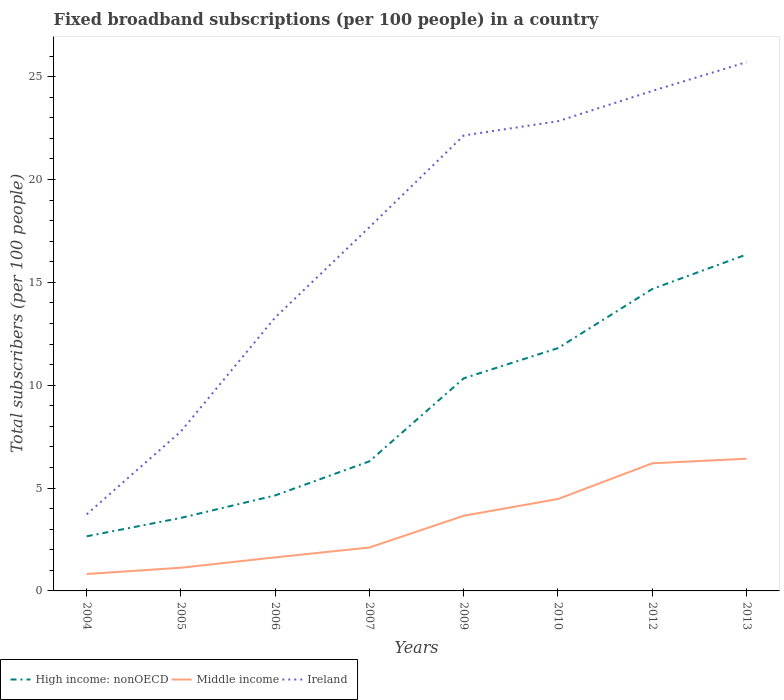How many different coloured lines are there?
Provide a succinct answer. 3. Does the line corresponding to Ireland intersect with the line corresponding to High income: nonOECD?
Ensure brevity in your answer.  No. Across all years, what is the maximum number of broadband subscriptions in High income: nonOECD?
Offer a terse response. 2.66. In which year was the number of broadband subscriptions in High income: nonOECD maximum?
Offer a very short reply. 2004. What is the total number of broadband subscriptions in High income: nonOECD in the graph?
Your answer should be very brief. -10.03. What is the difference between the highest and the second highest number of broadband subscriptions in Ireland?
Ensure brevity in your answer.  21.98. Is the number of broadband subscriptions in Ireland strictly greater than the number of broadband subscriptions in High income: nonOECD over the years?
Provide a succinct answer. No. How many lines are there?
Your response must be concise. 3. How many years are there in the graph?
Ensure brevity in your answer.  8. What is the difference between two consecutive major ticks on the Y-axis?
Your answer should be compact. 5. Does the graph contain grids?
Ensure brevity in your answer.  No. Where does the legend appear in the graph?
Your answer should be very brief. Bottom left. How many legend labels are there?
Your answer should be compact. 3. How are the legend labels stacked?
Give a very brief answer. Horizontal. What is the title of the graph?
Provide a succinct answer. Fixed broadband subscriptions (per 100 people) in a country. Does "Mali" appear as one of the legend labels in the graph?
Provide a short and direct response. No. What is the label or title of the Y-axis?
Your answer should be compact. Total subscribers (per 100 people). What is the Total subscribers (per 100 people) of High income: nonOECD in 2004?
Give a very brief answer. 2.66. What is the Total subscribers (per 100 people) in Middle income in 2004?
Give a very brief answer. 0.82. What is the Total subscribers (per 100 people) of Ireland in 2004?
Offer a terse response. 3.72. What is the Total subscribers (per 100 people) in High income: nonOECD in 2005?
Your answer should be very brief. 3.55. What is the Total subscribers (per 100 people) of Middle income in 2005?
Your answer should be compact. 1.13. What is the Total subscribers (per 100 people) in Ireland in 2005?
Offer a terse response. 7.76. What is the Total subscribers (per 100 people) of High income: nonOECD in 2006?
Ensure brevity in your answer.  4.64. What is the Total subscribers (per 100 people) in Middle income in 2006?
Give a very brief answer. 1.63. What is the Total subscribers (per 100 people) of Ireland in 2006?
Ensure brevity in your answer.  13.29. What is the Total subscribers (per 100 people) in High income: nonOECD in 2007?
Provide a succinct answer. 6.3. What is the Total subscribers (per 100 people) of Middle income in 2007?
Offer a very short reply. 2.11. What is the Total subscribers (per 100 people) of Ireland in 2007?
Give a very brief answer. 17.68. What is the Total subscribers (per 100 people) of High income: nonOECD in 2009?
Your answer should be compact. 10.33. What is the Total subscribers (per 100 people) in Middle income in 2009?
Provide a succinct answer. 3.65. What is the Total subscribers (per 100 people) in Ireland in 2009?
Make the answer very short. 22.14. What is the Total subscribers (per 100 people) of High income: nonOECD in 2010?
Provide a short and direct response. 11.8. What is the Total subscribers (per 100 people) in Middle income in 2010?
Your response must be concise. 4.47. What is the Total subscribers (per 100 people) of Ireland in 2010?
Your response must be concise. 22.83. What is the Total subscribers (per 100 people) in High income: nonOECD in 2012?
Give a very brief answer. 14.67. What is the Total subscribers (per 100 people) in Middle income in 2012?
Ensure brevity in your answer.  6.2. What is the Total subscribers (per 100 people) of Ireland in 2012?
Provide a short and direct response. 24.3. What is the Total subscribers (per 100 people) of High income: nonOECD in 2013?
Offer a very short reply. 16.35. What is the Total subscribers (per 100 people) of Middle income in 2013?
Offer a terse response. 6.43. What is the Total subscribers (per 100 people) of Ireland in 2013?
Offer a terse response. 25.7. Across all years, what is the maximum Total subscribers (per 100 people) in High income: nonOECD?
Provide a short and direct response. 16.35. Across all years, what is the maximum Total subscribers (per 100 people) in Middle income?
Ensure brevity in your answer.  6.43. Across all years, what is the maximum Total subscribers (per 100 people) of Ireland?
Ensure brevity in your answer.  25.7. Across all years, what is the minimum Total subscribers (per 100 people) of High income: nonOECD?
Provide a short and direct response. 2.66. Across all years, what is the minimum Total subscribers (per 100 people) in Middle income?
Ensure brevity in your answer.  0.82. Across all years, what is the minimum Total subscribers (per 100 people) of Ireland?
Make the answer very short. 3.72. What is the total Total subscribers (per 100 people) of High income: nonOECD in the graph?
Give a very brief answer. 70.31. What is the total Total subscribers (per 100 people) in Middle income in the graph?
Keep it short and to the point. 26.44. What is the total Total subscribers (per 100 people) in Ireland in the graph?
Your answer should be very brief. 137.43. What is the difference between the Total subscribers (per 100 people) of High income: nonOECD in 2004 and that in 2005?
Ensure brevity in your answer.  -0.89. What is the difference between the Total subscribers (per 100 people) in Middle income in 2004 and that in 2005?
Your response must be concise. -0.3. What is the difference between the Total subscribers (per 100 people) in Ireland in 2004 and that in 2005?
Offer a very short reply. -4.03. What is the difference between the Total subscribers (per 100 people) in High income: nonOECD in 2004 and that in 2006?
Ensure brevity in your answer.  -1.99. What is the difference between the Total subscribers (per 100 people) in Middle income in 2004 and that in 2006?
Keep it short and to the point. -0.81. What is the difference between the Total subscribers (per 100 people) of Ireland in 2004 and that in 2006?
Provide a succinct answer. -9.57. What is the difference between the Total subscribers (per 100 people) of High income: nonOECD in 2004 and that in 2007?
Keep it short and to the point. -3.65. What is the difference between the Total subscribers (per 100 people) in Middle income in 2004 and that in 2007?
Give a very brief answer. -1.29. What is the difference between the Total subscribers (per 100 people) of Ireland in 2004 and that in 2007?
Provide a succinct answer. -13.96. What is the difference between the Total subscribers (per 100 people) in High income: nonOECD in 2004 and that in 2009?
Keep it short and to the point. -7.68. What is the difference between the Total subscribers (per 100 people) of Middle income in 2004 and that in 2009?
Provide a succinct answer. -2.83. What is the difference between the Total subscribers (per 100 people) in Ireland in 2004 and that in 2009?
Ensure brevity in your answer.  -18.42. What is the difference between the Total subscribers (per 100 people) in High income: nonOECD in 2004 and that in 2010?
Your response must be concise. -9.15. What is the difference between the Total subscribers (per 100 people) of Middle income in 2004 and that in 2010?
Offer a very short reply. -3.64. What is the difference between the Total subscribers (per 100 people) in Ireland in 2004 and that in 2010?
Keep it short and to the point. -19.11. What is the difference between the Total subscribers (per 100 people) in High income: nonOECD in 2004 and that in 2012?
Offer a very short reply. -12.02. What is the difference between the Total subscribers (per 100 people) in Middle income in 2004 and that in 2012?
Give a very brief answer. -5.38. What is the difference between the Total subscribers (per 100 people) in Ireland in 2004 and that in 2012?
Keep it short and to the point. -20.58. What is the difference between the Total subscribers (per 100 people) of High income: nonOECD in 2004 and that in 2013?
Keep it short and to the point. -13.7. What is the difference between the Total subscribers (per 100 people) of Middle income in 2004 and that in 2013?
Make the answer very short. -5.6. What is the difference between the Total subscribers (per 100 people) of Ireland in 2004 and that in 2013?
Make the answer very short. -21.98. What is the difference between the Total subscribers (per 100 people) in High income: nonOECD in 2005 and that in 2006?
Make the answer very short. -1.09. What is the difference between the Total subscribers (per 100 people) of Middle income in 2005 and that in 2006?
Provide a short and direct response. -0.5. What is the difference between the Total subscribers (per 100 people) in Ireland in 2005 and that in 2006?
Your response must be concise. -5.54. What is the difference between the Total subscribers (per 100 people) in High income: nonOECD in 2005 and that in 2007?
Your answer should be compact. -2.75. What is the difference between the Total subscribers (per 100 people) in Middle income in 2005 and that in 2007?
Provide a succinct answer. -0.98. What is the difference between the Total subscribers (per 100 people) of Ireland in 2005 and that in 2007?
Your answer should be very brief. -9.93. What is the difference between the Total subscribers (per 100 people) of High income: nonOECD in 2005 and that in 2009?
Provide a succinct answer. -6.78. What is the difference between the Total subscribers (per 100 people) of Middle income in 2005 and that in 2009?
Offer a terse response. -2.53. What is the difference between the Total subscribers (per 100 people) of Ireland in 2005 and that in 2009?
Your response must be concise. -14.38. What is the difference between the Total subscribers (per 100 people) of High income: nonOECD in 2005 and that in 2010?
Keep it short and to the point. -8.25. What is the difference between the Total subscribers (per 100 people) of Middle income in 2005 and that in 2010?
Provide a short and direct response. -3.34. What is the difference between the Total subscribers (per 100 people) of Ireland in 2005 and that in 2010?
Provide a succinct answer. -15.07. What is the difference between the Total subscribers (per 100 people) in High income: nonOECD in 2005 and that in 2012?
Provide a succinct answer. -11.12. What is the difference between the Total subscribers (per 100 people) in Middle income in 2005 and that in 2012?
Your answer should be very brief. -5.08. What is the difference between the Total subscribers (per 100 people) of Ireland in 2005 and that in 2012?
Ensure brevity in your answer.  -16.55. What is the difference between the Total subscribers (per 100 people) in High income: nonOECD in 2005 and that in 2013?
Your answer should be compact. -12.8. What is the difference between the Total subscribers (per 100 people) of Middle income in 2005 and that in 2013?
Provide a succinct answer. -5.3. What is the difference between the Total subscribers (per 100 people) of Ireland in 2005 and that in 2013?
Keep it short and to the point. -17.94. What is the difference between the Total subscribers (per 100 people) of High income: nonOECD in 2006 and that in 2007?
Make the answer very short. -1.66. What is the difference between the Total subscribers (per 100 people) in Middle income in 2006 and that in 2007?
Your response must be concise. -0.48. What is the difference between the Total subscribers (per 100 people) in Ireland in 2006 and that in 2007?
Give a very brief answer. -4.39. What is the difference between the Total subscribers (per 100 people) of High income: nonOECD in 2006 and that in 2009?
Provide a short and direct response. -5.69. What is the difference between the Total subscribers (per 100 people) in Middle income in 2006 and that in 2009?
Your answer should be compact. -2.02. What is the difference between the Total subscribers (per 100 people) of Ireland in 2006 and that in 2009?
Your response must be concise. -8.85. What is the difference between the Total subscribers (per 100 people) of High income: nonOECD in 2006 and that in 2010?
Make the answer very short. -7.16. What is the difference between the Total subscribers (per 100 people) in Middle income in 2006 and that in 2010?
Keep it short and to the point. -2.84. What is the difference between the Total subscribers (per 100 people) in Ireland in 2006 and that in 2010?
Make the answer very short. -9.54. What is the difference between the Total subscribers (per 100 people) in High income: nonOECD in 2006 and that in 2012?
Provide a short and direct response. -10.03. What is the difference between the Total subscribers (per 100 people) in Middle income in 2006 and that in 2012?
Give a very brief answer. -4.57. What is the difference between the Total subscribers (per 100 people) of Ireland in 2006 and that in 2012?
Keep it short and to the point. -11.01. What is the difference between the Total subscribers (per 100 people) of High income: nonOECD in 2006 and that in 2013?
Your response must be concise. -11.71. What is the difference between the Total subscribers (per 100 people) of Middle income in 2006 and that in 2013?
Offer a very short reply. -4.79. What is the difference between the Total subscribers (per 100 people) in Ireland in 2006 and that in 2013?
Offer a terse response. -12.41. What is the difference between the Total subscribers (per 100 people) of High income: nonOECD in 2007 and that in 2009?
Offer a very short reply. -4.03. What is the difference between the Total subscribers (per 100 people) in Middle income in 2007 and that in 2009?
Your answer should be very brief. -1.54. What is the difference between the Total subscribers (per 100 people) in Ireland in 2007 and that in 2009?
Your answer should be compact. -4.45. What is the difference between the Total subscribers (per 100 people) in High income: nonOECD in 2007 and that in 2010?
Keep it short and to the point. -5.5. What is the difference between the Total subscribers (per 100 people) in Middle income in 2007 and that in 2010?
Your answer should be compact. -2.36. What is the difference between the Total subscribers (per 100 people) in Ireland in 2007 and that in 2010?
Provide a succinct answer. -5.15. What is the difference between the Total subscribers (per 100 people) in High income: nonOECD in 2007 and that in 2012?
Offer a very short reply. -8.37. What is the difference between the Total subscribers (per 100 people) of Middle income in 2007 and that in 2012?
Ensure brevity in your answer.  -4.09. What is the difference between the Total subscribers (per 100 people) in Ireland in 2007 and that in 2012?
Make the answer very short. -6.62. What is the difference between the Total subscribers (per 100 people) of High income: nonOECD in 2007 and that in 2013?
Provide a short and direct response. -10.05. What is the difference between the Total subscribers (per 100 people) of Middle income in 2007 and that in 2013?
Your response must be concise. -4.31. What is the difference between the Total subscribers (per 100 people) in Ireland in 2007 and that in 2013?
Offer a very short reply. -8.02. What is the difference between the Total subscribers (per 100 people) in High income: nonOECD in 2009 and that in 2010?
Give a very brief answer. -1.47. What is the difference between the Total subscribers (per 100 people) of Middle income in 2009 and that in 2010?
Give a very brief answer. -0.81. What is the difference between the Total subscribers (per 100 people) of Ireland in 2009 and that in 2010?
Offer a terse response. -0.69. What is the difference between the Total subscribers (per 100 people) in High income: nonOECD in 2009 and that in 2012?
Offer a very short reply. -4.34. What is the difference between the Total subscribers (per 100 people) in Middle income in 2009 and that in 2012?
Provide a succinct answer. -2.55. What is the difference between the Total subscribers (per 100 people) of Ireland in 2009 and that in 2012?
Your answer should be very brief. -2.17. What is the difference between the Total subscribers (per 100 people) in High income: nonOECD in 2009 and that in 2013?
Offer a terse response. -6.02. What is the difference between the Total subscribers (per 100 people) in Middle income in 2009 and that in 2013?
Make the answer very short. -2.77. What is the difference between the Total subscribers (per 100 people) in Ireland in 2009 and that in 2013?
Your answer should be compact. -3.56. What is the difference between the Total subscribers (per 100 people) of High income: nonOECD in 2010 and that in 2012?
Give a very brief answer. -2.87. What is the difference between the Total subscribers (per 100 people) of Middle income in 2010 and that in 2012?
Give a very brief answer. -1.74. What is the difference between the Total subscribers (per 100 people) in Ireland in 2010 and that in 2012?
Ensure brevity in your answer.  -1.47. What is the difference between the Total subscribers (per 100 people) of High income: nonOECD in 2010 and that in 2013?
Provide a succinct answer. -4.55. What is the difference between the Total subscribers (per 100 people) of Middle income in 2010 and that in 2013?
Offer a very short reply. -1.96. What is the difference between the Total subscribers (per 100 people) in Ireland in 2010 and that in 2013?
Offer a terse response. -2.87. What is the difference between the Total subscribers (per 100 people) of High income: nonOECD in 2012 and that in 2013?
Your answer should be very brief. -1.68. What is the difference between the Total subscribers (per 100 people) in Middle income in 2012 and that in 2013?
Offer a terse response. -0.22. What is the difference between the Total subscribers (per 100 people) in Ireland in 2012 and that in 2013?
Your answer should be very brief. -1.4. What is the difference between the Total subscribers (per 100 people) of High income: nonOECD in 2004 and the Total subscribers (per 100 people) of Middle income in 2005?
Offer a very short reply. 1.53. What is the difference between the Total subscribers (per 100 people) in High income: nonOECD in 2004 and the Total subscribers (per 100 people) in Ireland in 2005?
Your answer should be very brief. -5.1. What is the difference between the Total subscribers (per 100 people) in Middle income in 2004 and the Total subscribers (per 100 people) in Ireland in 2005?
Offer a terse response. -6.93. What is the difference between the Total subscribers (per 100 people) of High income: nonOECD in 2004 and the Total subscribers (per 100 people) of Ireland in 2006?
Keep it short and to the point. -10.64. What is the difference between the Total subscribers (per 100 people) in Middle income in 2004 and the Total subscribers (per 100 people) in Ireland in 2006?
Offer a terse response. -12.47. What is the difference between the Total subscribers (per 100 people) of High income: nonOECD in 2004 and the Total subscribers (per 100 people) of Middle income in 2007?
Provide a short and direct response. 0.54. What is the difference between the Total subscribers (per 100 people) in High income: nonOECD in 2004 and the Total subscribers (per 100 people) in Ireland in 2007?
Provide a succinct answer. -15.03. What is the difference between the Total subscribers (per 100 people) of Middle income in 2004 and the Total subscribers (per 100 people) of Ireland in 2007?
Provide a succinct answer. -16.86. What is the difference between the Total subscribers (per 100 people) of High income: nonOECD in 2004 and the Total subscribers (per 100 people) of Middle income in 2009?
Give a very brief answer. -1. What is the difference between the Total subscribers (per 100 people) in High income: nonOECD in 2004 and the Total subscribers (per 100 people) in Ireland in 2009?
Provide a short and direct response. -19.48. What is the difference between the Total subscribers (per 100 people) of Middle income in 2004 and the Total subscribers (per 100 people) of Ireland in 2009?
Ensure brevity in your answer.  -21.32. What is the difference between the Total subscribers (per 100 people) of High income: nonOECD in 2004 and the Total subscribers (per 100 people) of Middle income in 2010?
Make the answer very short. -1.81. What is the difference between the Total subscribers (per 100 people) of High income: nonOECD in 2004 and the Total subscribers (per 100 people) of Ireland in 2010?
Offer a very short reply. -20.18. What is the difference between the Total subscribers (per 100 people) of Middle income in 2004 and the Total subscribers (per 100 people) of Ireland in 2010?
Ensure brevity in your answer.  -22.01. What is the difference between the Total subscribers (per 100 people) in High income: nonOECD in 2004 and the Total subscribers (per 100 people) in Middle income in 2012?
Your response must be concise. -3.55. What is the difference between the Total subscribers (per 100 people) of High income: nonOECD in 2004 and the Total subscribers (per 100 people) of Ireland in 2012?
Provide a short and direct response. -21.65. What is the difference between the Total subscribers (per 100 people) of Middle income in 2004 and the Total subscribers (per 100 people) of Ireland in 2012?
Offer a terse response. -23.48. What is the difference between the Total subscribers (per 100 people) of High income: nonOECD in 2004 and the Total subscribers (per 100 people) of Middle income in 2013?
Your response must be concise. -3.77. What is the difference between the Total subscribers (per 100 people) of High income: nonOECD in 2004 and the Total subscribers (per 100 people) of Ireland in 2013?
Make the answer very short. -23.05. What is the difference between the Total subscribers (per 100 people) in Middle income in 2004 and the Total subscribers (per 100 people) in Ireland in 2013?
Offer a terse response. -24.88. What is the difference between the Total subscribers (per 100 people) in High income: nonOECD in 2005 and the Total subscribers (per 100 people) in Middle income in 2006?
Give a very brief answer. 1.92. What is the difference between the Total subscribers (per 100 people) in High income: nonOECD in 2005 and the Total subscribers (per 100 people) in Ireland in 2006?
Provide a short and direct response. -9.74. What is the difference between the Total subscribers (per 100 people) in Middle income in 2005 and the Total subscribers (per 100 people) in Ireland in 2006?
Provide a succinct answer. -12.16. What is the difference between the Total subscribers (per 100 people) of High income: nonOECD in 2005 and the Total subscribers (per 100 people) of Middle income in 2007?
Give a very brief answer. 1.44. What is the difference between the Total subscribers (per 100 people) in High income: nonOECD in 2005 and the Total subscribers (per 100 people) in Ireland in 2007?
Your answer should be very brief. -14.13. What is the difference between the Total subscribers (per 100 people) in Middle income in 2005 and the Total subscribers (per 100 people) in Ireland in 2007?
Provide a succinct answer. -16.56. What is the difference between the Total subscribers (per 100 people) in High income: nonOECD in 2005 and the Total subscribers (per 100 people) in Middle income in 2009?
Offer a very short reply. -0.1. What is the difference between the Total subscribers (per 100 people) in High income: nonOECD in 2005 and the Total subscribers (per 100 people) in Ireland in 2009?
Make the answer very short. -18.59. What is the difference between the Total subscribers (per 100 people) of Middle income in 2005 and the Total subscribers (per 100 people) of Ireland in 2009?
Give a very brief answer. -21.01. What is the difference between the Total subscribers (per 100 people) in High income: nonOECD in 2005 and the Total subscribers (per 100 people) in Middle income in 2010?
Provide a succinct answer. -0.92. What is the difference between the Total subscribers (per 100 people) in High income: nonOECD in 2005 and the Total subscribers (per 100 people) in Ireland in 2010?
Your response must be concise. -19.28. What is the difference between the Total subscribers (per 100 people) of Middle income in 2005 and the Total subscribers (per 100 people) of Ireland in 2010?
Keep it short and to the point. -21.7. What is the difference between the Total subscribers (per 100 people) of High income: nonOECD in 2005 and the Total subscribers (per 100 people) of Middle income in 2012?
Ensure brevity in your answer.  -2.65. What is the difference between the Total subscribers (per 100 people) of High income: nonOECD in 2005 and the Total subscribers (per 100 people) of Ireland in 2012?
Provide a succinct answer. -20.75. What is the difference between the Total subscribers (per 100 people) of Middle income in 2005 and the Total subscribers (per 100 people) of Ireland in 2012?
Provide a succinct answer. -23.18. What is the difference between the Total subscribers (per 100 people) in High income: nonOECD in 2005 and the Total subscribers (per 100 people) in Middle income in 2013?
Offer a terse response. -2.88. What is the difference between the Total subscribers (per 100 people) of High income: nonOECD in 2005 and the Total subscribers (per 100 people) of Ireland in 2013?
Offer a very short reply. -22.15. What is the difference between the Total subscribers (per 100 people) in Middle income in 2005 and the Total subscribers (per 100 people) in Ireland in 2013?
Make the answer very short. -24.57. What is the difference between the Total subscribers (per 100 people) in High income: nonOECD in 2006 and the Total subscribers (per 100 people) in Middle income in 2007?
Ensure brevity in your answer.  2.53. What is the difference between the Total subscribers (per 100 people) of High income: nonOECD in 2006 and the Total subscribers (per 100 people) of Ireland in 2007?
Keep it short and to the point. -13.04. What is the difference between the Total subscribers (per 100 people) in Middle income in 2006 and the Total subscribers (per 100 people) in Ireland in 2007?
Keep it short and to the point. -16.05. What is the difference between the Total subscribers (per 100 people) in High income: nonOECD in 2006 and the Total subscribers (per 100 people) in Ireland in 2009?
Your answer should be very brief. -17.5. What is the difference between the Total subscribers (per 100 people) in Middle income in 2006 and the Total subscribers (per 100 people) in Ireland in 2009?
Give a very brief answer. -20.51. What is the difference between the Total subscribers (per 100 people) of High income: nonOECD in 2006 and the Total subscribers (per 100 people) of Middle income in 2010?
Ensure brevity in your answer.  0.18. What is the difference between the Total subscribers (per 100 people) in High income: nonOECD in 2006 and the Total subscribers (per 100 people) in Ireland in 2010?
Keep it short and to the point. -18.19. What is the difference between the Total subscribers (per 100 people) in Middle income in 2006 and the Total subscribers (per 100 people) in Ireland in 2010?
Offer a terse response. -21.2. What is the difference between the Total subscribers (per 100 people) in High income: nonOECD in 2006 and the Total subscribers (per 100 people) in Middle income in 2012?
Your response must be concise. -1.56. What is the difference between the Total subscribers (per 100 people) in High income: nonOECD in 2006 and the Total subscribers (per 100 people) in Ireland in 2012?
Keep it short and to the point. -19.66. What is the difference between the Total subscribers (per 100 people) in Middle income in 2006 and the Total subscribers (per 100 people) in Ireland in 2012?
Offer a terse response. -22.67. What is the difference between the Total subscribers (per 100 people) of High income: nonOECD in 2006 and the Total subscribers (per 100 people) of Middle income in 2013?
Your answer should be compact. -1.78. What is the difference between the Total subscribers (per 100 people) of High income: nonOECD in 2006 and the Total subscribers (per 100 people) of Ireland in 2013?
Make the answer very short. -21.06. What is the difference between the Total subscribers (per 100 people) of Middle income in 2006 and the Total subscribers (per 100 people) of Ireland in 2013?
Provide a succinct answer. -24.07. What is the difference between the Total subscribers (per 100 people) in High income: nonOECD in 2007 and the Total subscribers (per 100 people) in Middle income in 2009?
Offer a very short reply. 2.65. What is the difference between the Total subscribers (per 100 people) in High income: nonOECD in 2007 and the Total subscribers (per 100 people) in Ireland in 2009?
Your answer should be very brief. -15.84. What is the difference between the Total subscribers (per 100 people) in Middle income in 2007 and the Total subscribers (per 100 people) in Ireland in 2009?
Ensure brevity in your answer.  -20.03. What is the difference between the Total subscribers (per 100 people) in High income: nonOECD in 2007 and the Total subscribers (per 100 people) in Middle income in 2010?
Give a very brief answer. 1.83. What is the difference between the Total subscribers (per 100 people) in High income: nonOECD in 2007 and the Total subscribers (per 100 people) in Ireland in 2010?
Offer a very short reply. -16.53. What is the difference between the Total subscribers (per 100 people) in Middle income in 2007 and the Total subscribers (per 100 people) in Ireland in 2010?
Offer a terse response. -20.72. What is the difference between the Total subscribers (per 100 people) in High income: nonOECD in 2007 and the Total subscribers (per 100 people) in Middle income in 2012?
Your response must be concise. 0.1. What is the difference between the Total subscribers (per 100 people) of High income: nonOECD in 2007 and the Total subscribers (per 100 people) of Ireland in 2012?
Offer a terse response. -18. What is the difference between the Total subscribers (per 100 people) of Middle income in 2007 and the Total subscribers (per 100 people) of Ireland in 2012?
Provide a succinct answer. -22.19. What is the difference between the Total subscribers (per 100 people) in High income: nonOECD in 2007 and the Total subscribers (per 100 people) in Middle income in 2013?
Make the answer very short. -0.12. What is the difference between the Total subscribers (per 100 people) of High income: nonOECD in 2007 and the Total subscribers (per 100 people) of Ireland in 2013?
Ensure brevity in your answer.  -19.4. What is the difference between the Total subscribers (per 100 people) of Middle income in 2007 and the Total subscribers (per 100 people) of Ireland in 2013?
Make the answer very short. -23.59. What is the difference between the Total subscribers (per 100 people) in High income: nonOECD in 2009 and the Total subscribers (per 100 people) in Middle income in 2010?
Your response must be concise. 5.87. What is the difference between the Total subscribers (per 100 people) in High income: nonOECD in 2009 and the Total subscribers (per 100 people) in Ireland in 2010?
Ensure brevity in your answer.  -12.5. What is the difference between the Total subscribers (per 100 people) of Middle income in 2009 and the Total subscribers (per 100 people) of Ireland in 2010?
Ensure brevity in your answer.  -19.18. What is the difference between the Total subscribers (per 100 people) of High income: nonOECD in 2009 and the Total subscribers (per 100 people) of Middle income in 2012?
Provide a succinct answer. 4.13. What is the difference between the Total subscribers (per 100 people) of High income: nonOECD in 2009 and the Total subscribers (per 100 people) of Ireland in 2012?
Provide a succinct answer. -13.97. What is the difference between the Total subscribers (per 100 people) of Middle income in 2009 and the Total subscribers (per 100 people) of Ireland in 2012?
Give a very brief answer. -20.65. What is the difference between the Total subscribers (per 100 people) of High income: nonOECD in 2009 and the Total subscribers (per 100 people) of Middle income in 2013?
Your response must be concise. 3.91. What is the difference between the Total subscribers (per 100 people) in High income: nonOECD in 2009 and the Total subscribers (per 100 people) in Ireland in 2013?
Provide a short and direct response. -15.37. What is the difference between the Total subscribers (per 100 people) of Middle income in 2009 and the Total subscribers (per 100 people) of Ireland in 2013?
Keep it short and to the point. -22.05. What is the difference between the Total subscribers (per 100 people) in High income: nonOECD in 2010 and the Total subscribers (per 100 people) in Middle income in 2012?
Make the answer very short. 5.6. What is the difference between the Total subscribers (per 100 people) of High income: nonOECD in 2010 and the Total subscribers (per 100 people) of Ireland in 2012?
Provide a short and direct response. -12.5. What is the difference between the Total subscribers (per 100 people) of Middle income in 2010 and the Total subscribers (per 100 people) of Ireland in 2012?
Offer a terse response. -19.84. What is the difference between the Total subscribers (per 100 people) in High income: nonOECD in 2010 and the Total subscribers (per 100 people) in Middle income in 2013?
Your answer should be compact. 5.38. What is the difference between the Total subscribers (per 100 people) in High income: nonOECD in 2010 and the Total subscribers (per 100 people) in Ireland in 2013?
Offer a very short reply. -13.9. What is the difference between the Total subscribers (per 100 people) of Middle income in 2010 and the Total subscribers (per 100 people) of Ireland in 2013?
Provide a succinct answer. -21.23. What is the difference between the Total subscribers (per 100 people) of High income: nonOECD in 2012 and the Total subscribers (per 100 people) of Middle income in 2013?
Keep it short and to the point. 8.25. What is the difference between the Total subscribers (per 100 people) in High income: nonOECD in 2012 and the Total subscribers (per 100 people) in Ireland in 2013?
Ensure brevity in your answer.  -11.03. What is the difference between the Total subscribers (per 100 people) of Middle income in 2012 and the Total subscribers (per 100 people) of Ireland in 2013?
Your answer should be very brief. -19.5. What is the average Total subscribers (per 100 people) in High income: nonOECD per year?
Your response must be concise. 8.79. What is the average Total subscribers (per 100 people) in Middle income per year?
Provide a succinct answer. 3.31. What is the average Total subscribers (per 100 people) of Ireland per year?
Provide a short and direct response. 17.18. In the year 2004, what is the difference between the Total subscribers (per 100 people) in High income: nonOECD and Total subscribers (per 100 people) in Middle income?
Offer a very short reply. 1.83. In the year 2004, what is the difference between the Total subscribers (per 100 people) of High income: nonOECD and Total subscribers (per 100 people) of Ireland?
Make the answer very short. -1.07. In the year 2004, what is the difference between the Total subscribers (per 100 people) of Middle income and Total subscribers (per 100 people) of Ireland?
Provide a succinct answer. -2.9. In the year 2005, what is the difference between the Total subscribers (per 100 people) of High income: nonOECD and Total subscribers (per 100 people) of Middle income?
Give a very brief answer. 2.42. In the year 2005, what is the difference between the Total subscribers (per 100 people) of High income: nonOECD and Total subscribers (per 100 people) of Ireland?
Offer a terse response. -4.21. In the year 2005, what is the difference between the Total subscribers (per 100 people) in Middle income and Total subscribers (per 100 people) in Ireland?
Your answer should be compact. -6.63. In the year 2006, what is the difference between the Total subscribers (per 100 people) in High income: nonOECD and Total subscribers (per 100 people) in Middle income?
Give a very brief answer. 3.01. In the year 2006, what is the difference between the Total subscribers (per 100 people) in High income: nonOECD and Total subscribers (per 100 people) in Ireland?
Provide a succinct answer. -8.65. In the year 2006, what is the difference between the Total subscribers (per 100 people) of Middle income and Total subscribers (per 100 people) of Ireland?
Offer a terse response. -11.66. In the year 2007, what is the difference between the Total subscribers (per 100 people) of High income: nonOECD and Total subscribers (per 100 people) of Middle income?
Ensure brevity in your answer.  4.19. In the year 2007, what is the difference between the Total subscribers (per 100 people) of High income: nonOECD and Total subscribers (per 100 people) of Ireland?
Keep it short and to the point. -11.38. In the year 2007, what is the difference between the Total subscribers (per 100 people) of Middle income and Total subscribers (per 100 people) of Ireland?
Provide a succinct answer. -15.57. In the year 2009, what is the difference between the Total subscribers (per 100 people) in High income: nonOECD and Total subscribers (per 100 people) in Middle income?
Your response must be concise. 6.68. In the year 2009, what is the difference between the Total subscribers (per 100 people) of High income: nonOECD and Total subscribers (per 100 people) of Ireland?
Keep it short and to the point. -11.8. In the year 2009, what is the difference between the Total subscribers (per 100 people) of Middle income and Total subscribers (per 100 people) of Ireland?
Make the answer very short. -18.48. In the year 2010, what is the difference between the Total subscribers (per 100 people) of High income: nonOECD and Total subscribers (per 100 people) of Middle income?
Your answer should be very brief. 7.33. In the year 2010, what is the difference between the Total subscribers (per 100 people) in High income: nonOECD and Total subscribers (per 100 people) in Ireland?
Offer a very short reply. -11.03. In the year 2010, what is the difference between the Total subscribers (per 100 people) in Middle income and Total subscribers (per 100 people) in Ireland?
Provide a short and direct response. -18.36. In the year 2012, what is the difference between the Total subscribers (per 100 people) of High income: nonOECD and Total subscribers (per 100 people) of Middle income?
Give a very brief answer. 8.47. In the year 2012, what is the difference between the Total subscribers (per 100 people) in High income: nonOECD and Total subscribers (per 100 people) in Ireland?
Ensure brevity in your answer.  -9.63. In the year 2012, what is the difference between the Total subscribers (per 100 people) of Middle income and Total subscribers (per 100 people) of Ireland?
Offer a very short reply. -18.1. In the year 2013, what is the difference between the Total subscribers (per 100 people) of High income: nonOECD and Total subscribers (per 100 people) of Middle income?
Keep it short and to the point. 9.93. In the year 2013, what is the difference between the Total subscribers (per 100 people) of High income: nonOECD and Total subscribers (per 100 people) of Ireland?
Offer a terse response. -9.35. In the year 2013, what is the difference between the Total subscribers (per 100 people) in Middle income and Total subscribers (per 100 people) in Ireland?
Give a very brief answer. -19.28. What is the ratio of the Total subscribers (per 100 people) in High income: nonOECD in 2004 to that in 2005?
Keep it short and to the point. 0.75. What is the ratio of the Total subscribers (per 100 people) in Middle income in 2004 to that in 2005?
Your response must be concise. 0.73. What is the ratio of the Total subscribers (per 100 people) in Ireland in 2004 to that in 2005?
Keep it short and to the point. 0.48. What is the ratio of the Total subscribers (per 100 people) in High income: nonOECD in 2004 to that in 2006?
Make the answer very short. 0.57. What is the ratio of the Total subscribers (per 100 people) in Middle income in 2004 to that in 2006?
Ensure brevity in your answer.  0.5. What is the ratio of the Total subscribers (per 100 people) in Ireland in 2004 to that in 2006?
Make the answer very short. 0.28. What is the ratio of the Total subscribers (per 100 people) in High income: nonOECD in 2004 to that in 2007?
Offer a terse response. 0.42. What is the ratio of the Total subscribers (per 100 people) of Middle income in 2004 to that in 2007?
Provide a short and direct response. 0.39. What is the ratio of the Total subscribers (per 100 people) in Ireland in 2004 to that in 2007?
Ensure brevity in your answer.  0.21. What is the ratio of the Total subscribers (per 100 people) in High income: nonOECD in 2004 to that in 2009?
Your response must be concise. 0.26. What is the ratio of the Total subscribers (per 100 people) of Middle income in 2004 to that in 2009?
Offer a terse response. 0.23. What is the ratio of the Total subscribers (per 100 people) of Ireland in 2004 to that in 2009?
Provide a succinct answer. 0.17. What is the ratio of the Total subscribers (per 100 people) of High income: nonOECD in 2004 to that in 2010?
Provide a short and direct response. 0.23. What is the ratio of the Total subscribers (per 100 people) of Middle income in 2004 to that in 2010?
Provide a short and direct response. 0.18. What is the ratio of the Total subscribers (per 100 people) in Ireland in 2004 to that in 2010?
Give a very brief answer. 0.16. What is the ratio of the Total subscribers (per 100 people) in High income: nonOECD in 2004 to that in 2012?
Your answer should be very brief. 0.18. What is the ratio of the Total subscribers (per 100 people) in Middle income in 2004 to that in 2012?
Keep it short and to the point. 0.13. What is the ratio of the Total subscribers (per 100 people) of Ireland in 2004 to that in 2012?
Ensure brevity in your answer.  0.15. What is the ratio of the Total subscribers (per 100 people) of High income: nonOECD in 2004 to that in 2013?
Give a very brief answer. 0.16. What is the ratio of the Total subscribers (per 100 people) of Middle income in 2004 to that in 2013?
Give a very brief answer. 0.13. What is the ratio of the Total subscribers (per 100 people) of Ireland in 2004 to that in 2013?
Provide a short and direct response. 0.14. What is the ratio of the Total subscribers (per 100 people) of High income: nonOECD in 2005 to that in 2006?
Provide a short and direct response. 0.76. What is the ratio of the Total subscribers (per 100 people) of Middle income in 2005 to that in 2006?
Ensure brevity in your answer.  0.69. What is the ratio of the Total subscribers (per 100 people) in Ireland in 2005 to that in 2006?
Provide a short and direct response. 0.58. What is the ratio of the Total subscribers (per 100 people) of High income: nonOECD in 2005 to that in 2007?
Ensure brevity in your answer.  0.56. What is the ratio of the Total subscribers (per 100 people) of Middle income in 2005 to that in 2007?
Provide a succinct answer. 0.53. What is the ratio of the Total subscribers (per 100 people) in Ireland in 2005 to that in 2007?
Your answer should be very brief. 0.44. What is the ratio of the Total subscribers (per 100 people) in High income: nonOECD in 2005 to that in 2009?
Provide a succinct answer. 0.34. What is the ratio of the Total subscribers (per 100 people) in Middle income in 2005 to that in 2009?
Offer a terse response. 0.31. What is the ratio of the Total subscribers (per 100 people) in Ireland in 2005 to that in 2009?
Offer a terse response. 0.35. What is the ratio of the Total subscribers (per 100 people) in High income: nonOECD in 2005 to that in 2010?
Ensure brevity in your answer.  0.3. What is the ratio of the Total subscribers (per 100 people) in Middle income in 2005 to that in 2010?
Provide a succinct answer. 0.25. What is the ratio of the Total subscribers (per 100 people) of Ireland in 2005 to that in 2010?
Provide a short and direct response. 0.34. What is the ratio of the Total subscribers (per 100 people) of High income: nonOECD in 2005 to that in 2012?
Your answer should be compact. 0.24. What is the ratio of the Total subscribers (per 100 people) of Middle income in 2005 to that in 2012?
Give a very brief answer. 0.18. What is the ratio of the Total subscribers (per 100 people) of Ireland in 2005 to that in 2012?
Your answer should be very brief. 0.32. What is the ratio of the Total subscribers (per 100 people) in High income: nonOECD in 2005 to that in 2013?
Your response must be concise. 0.22. What is the ratio of the Total subscribers (per 100 people) of Middle income in 2005 to that in 2013?
Your response must be concise. 0.18. What is the ratio of the Total subscribers (per 100 people) of Ireland in 2005 to that in 2013?
Provide a short and direct response. 0.3. What is the ratio of the Total subscribers (per 100 people) of High income: nonOECD in 2006 to that in 2007?
Keep it short and to the point. 0.74. What is the ratio of the Total subscribers (per 100 people) in Middle income in 2006 to that in 2007?
Your response must be concise. 0.77. What is the ratio of the Total subscribers (per 100 people) of Ireland in 2006 to that in 2007?
Offer a terse response. 0.75. What is the ratio of the Total subscribers (per 100 people) in High income: nonOECD in 2006 to that in 2009?
Provide a short and direct response. 0.45. What is the ratio of the Total subscribers (per 100 people) in Middle income in 2006 to that in 2009?
Make the answer very short. 0.45. What is the ratio of the Total subscribers (per 100 people) in Ireland in 2006 to that in 2009?
Give a very brief answer. 0.6. What is the ratio of the Total subscribers (per 100 people) of High income: nonOECD in 2006 to that in 2010?
Your response must be concise. 0.39. What is the ratio of the Total subscribers (per 100 people) in Middle income in 2006 to that in 2010?
Provide a succinct answer. 0.37. What is the ratio of the Total subscribers (per 100 people) of Ireland in 2006 to that in 2010?
Keep it short and to the point. 0.58. What is the ratio of the Total subscribers (per 100 people) in High income: nonOECD in 2006 to that in 2012?
Make the answer very short. 0.32. What is the ratio of the Total subscribers (per 100 people) of Middle income in 2006 to that in 2012?
Keep it short and to the point. 0.26. What is the ratio of the Total subscribers (per 100 people) of Ireland in 2006 to that in 2012?
Offer a very short reply. 0.55. What is the ratio of the Total subscribers (per 100 people) in High income: nonOECD in 2006 to that in 2013?
Make the answer very short. 0.28. What is the ratio of the Total subscribers (per 100 people) of Middle income in 2006 to that in 2013?
Give a very brief answer. 0.25. What is the ratio of the Total subscribers (per 100 people) of Ireland in 2006 to that in 2013?
Offer a very short reply. 0.52. What is the ratio of the Total subscribers (per 100 people) in High income: nonOECD in 2007 to that in 2009?
Keep it short and to the point. 0.61. What is the ratio of the Total subscribers (per 100 people) in Middle income in 2007 to that in 2009?
Make the answer very short. 0.58. What is the ratio of the Total subscribers (per 100 people) in Ireland in 2007 to that in 2009?
Provide a short and direct response. 0.8. What is the ratio of the Total subscribers (per 100 people) of High income: nonOECD in 2007 to that in 2010?
Keep it short and to the point. 0.53. What is the ratio of the Total subscribers (per 100 people) in Middle income in 2007 to that in 2010?
Offer a terse response. 0.47. What is the ratio of the Total subscribers (per 100 people) of Ireland in 2007 to that in 2010?
Keep it short and to the point. 0.77. What is the ratio of the Total subscribers (per 100 people) in High income: nonOECD in 2007 to that in 2012?
Give a very brief answer. 0.43. What is the ratio of the Total subscribers (per 100 people) in Middle income in 2007 to that in 2012?
Your answer should be very brief. 0.34. What is the ratio of the Total subscribers (per 100 people) of Ireland in 2007 to that in 2012?
Give a very brief answer. 0.73. What is the ratio of the Total subscribers (per 100 people) of High income: nonOECD in 2007 to that in 2013?
Keep it short and to the point. 0.39. What is the ratio of the Total subscribers (per 100 people) of Middle income in 2007 to that in 2013?
Provide a short and direct response. 0.33. What is the ratio of the Total subscribers (per 100 people) of Ireland in 2007 to that in 2013?
Provide a succinct answer. 0.69. What is the ratio of the Total subscribers (per 100 people) in High income: nonOECD in 2009 to that in 2010?
Keep it short and to the point. 0.88. What is the ratio of the Total subscribers (per 100 people) of Middle income in 2009 to that in 2010?
Offer a very short reply. 0.82. What is the ratio of the Total subscribers (per 100 people) in Ireland in 2009 to that in 2010?
Provide a short and direct response. 0.97. What is the ratio of the Total subscribers (per 100 people) of High income: nonOECD in 2009 to that in 2012?
Offer a very short reply. 0.7. What is the ratio of the Total subscribers (per 100 people) of Middle income in 2009 to that in 2012?
Your response must be concise. 0.59. What is the ratio of the Total subscribers (per 100 people) in Ireland in 2009 to that in 2012?
Your answer should be compact. 0.91. What is the ratio of the Total subscribers (per 100 people) in High income: nonOECD in 2009 to that in 2013?
Provide a short and direct response. 0.63. What is the ratio of the Total subscribers (per 100 people) of Middle income in 2009 to that in 2013?
Offer a very short reply. 0.57. What is the ratio of the Total subscribers (per 100 people) of Ireland in 2009 to that in 2013?
Your response must be concise. 0.86. What is the ratio of the Total subscribers (per 100 people) in High income: nonOECD in 2010 to that in 2012?
Offer a very short reply. 0.8. What is the ratio of the Total subscribers (per 100 people) of Middle income in 2010 to that in 2012?
Ensure brevity in your answer.  0.72. What is the ratio of the Total subscribers (per 100 people) in Ireland in 2010 to that in 2012?
Give a very brief answer. 0.94. What is the ratio of the Total subscribers (per 100 people) in High income: nonOECD in 2010 to that in 2013?
Ensure brevity in your answer.  0.72. What is the ratio of the Total subscribers (per 100 people) of Middle income in 2010 to that in 2013?
Provide a succinct answer. 0.7. What is the ratio of the Total subscribers (per 100 people) of Ireland in 2010 to that in 2013?
Keep it short and to the point. 0.89. What is the ratio of the Total subscribers (per 100 people) in High income: nonOECD in 2012 to that in 2013?
Offer a terse response. 0.9. What is the ratio of the Total subscribers (per 100 people) in Middle income in 2012 to that in 2013?
Provide a short and direct response. 0.97. What is the ratio of the Total subscribers (per 100 people) of Ireland in 2012 to that in 2013?
Ensure brevity in your answer.  0.95. What is the difference between the highest and the second highest Total subscribers (per 100 people) in High income: nonOECD?
Your answer should be very brief. 1.68. What is the difference between the highest and the second highest Total subscribers (per 100 people) in Middle income?
Your answer should be very brief. 0.22. What is the difference between the highest and the second highest Total subscribers (per 100 people) of Ireland?
Ensure brevity in your answer.  1.4. What is the difference between the highest and the lowest Total subscribers (per 100 people) of High income: nonOECD?
Your answer should be very brief. 13.7. What is the difference between the highest and the lowest Total subscribers (per 100 people) in Middle income?
Make the answer very short. 5.6. What is the difference between the highest and the lowest Total subscribers (per 100 people) in Ireland?
Your answer should be compact. 21.98. 